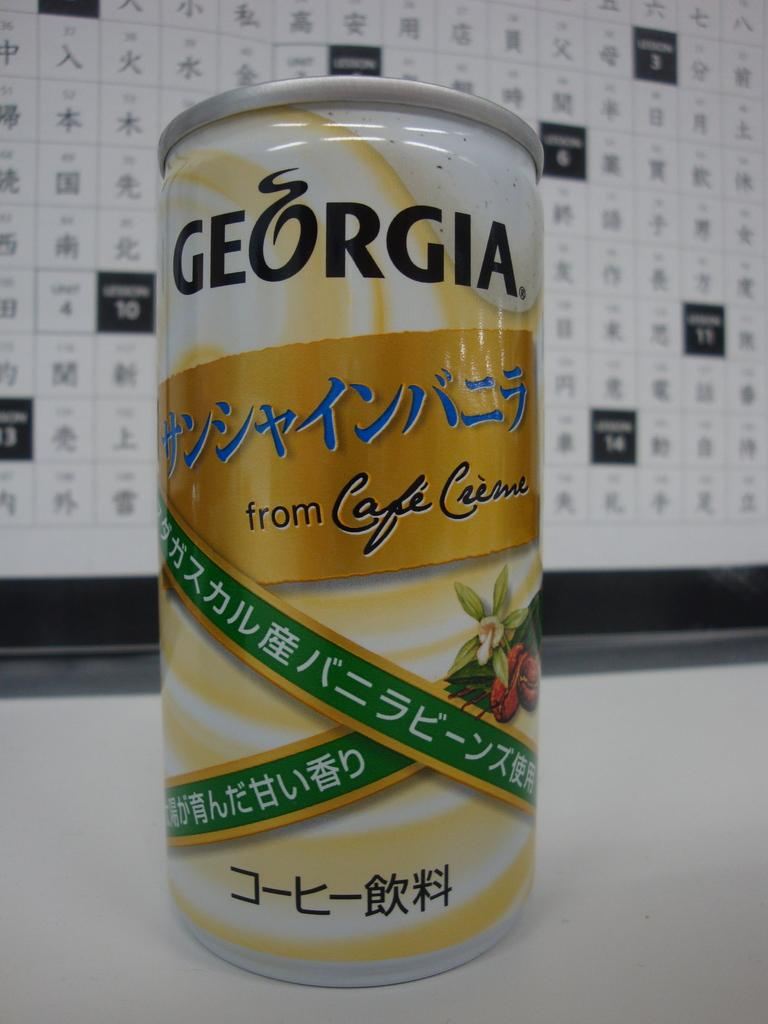Provide a one-sentence caption for the provided image. A can of Georgia sitting in front of a chart. 